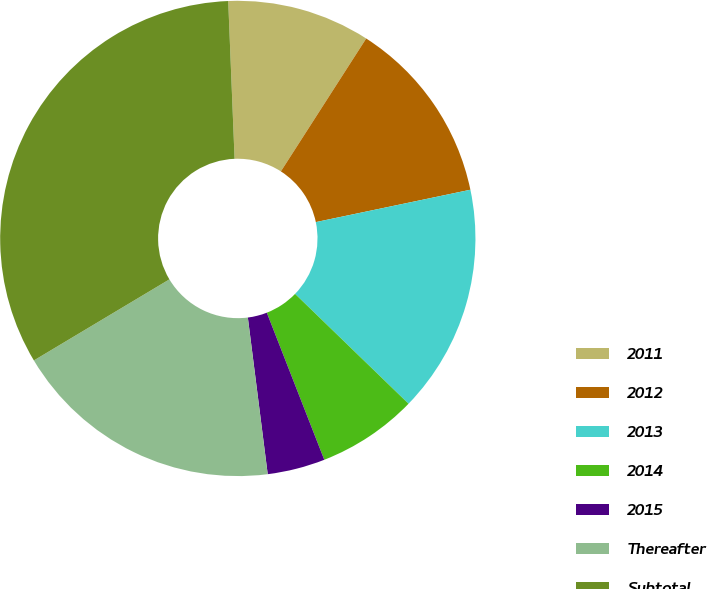Convert chart. <chart><loc_0><loc_0><loc_500><loc_500><pie_chart><fcel>2011<fcel>2012<fcel>2013<fcel>2014<fcel>2015<fcel>Thereafter<fcel>Subtotal<nl><fcel>9.73%<fcel>12.63%<fcel>15.53%<fcel>6.83%<fcel>3.92%<fcel>18.43%<fcel>32.94%<nl></chart> 